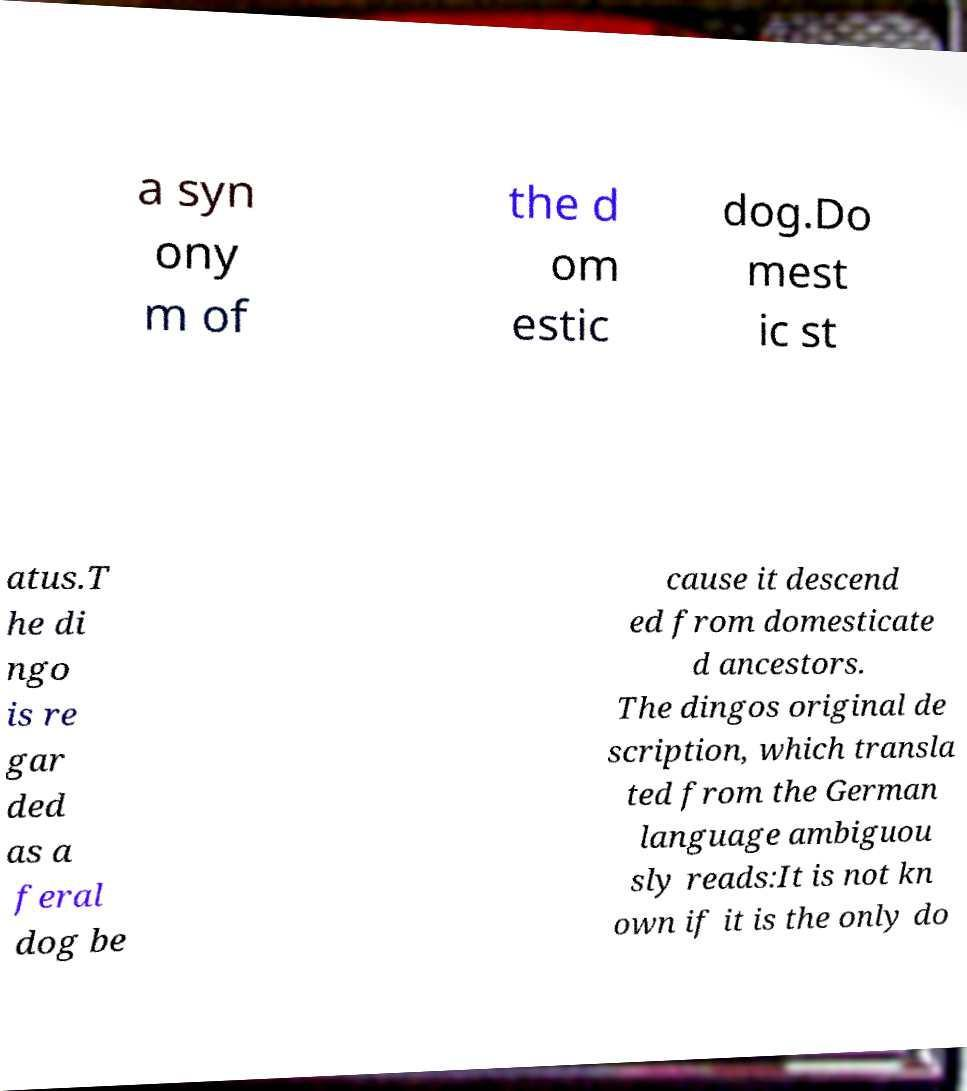Could you assist in decoding the text presented in this image and type it out clearly? a syn ony m of the d om estic dog.Do mest ic st atus.T he di ngo is re gar ded as a feral dog be cause it descend ed from domesticate d ancestors. The dingos original de scription, which transla ted from the German language ambiguou sly reads:It is not kn own if it is the only do 